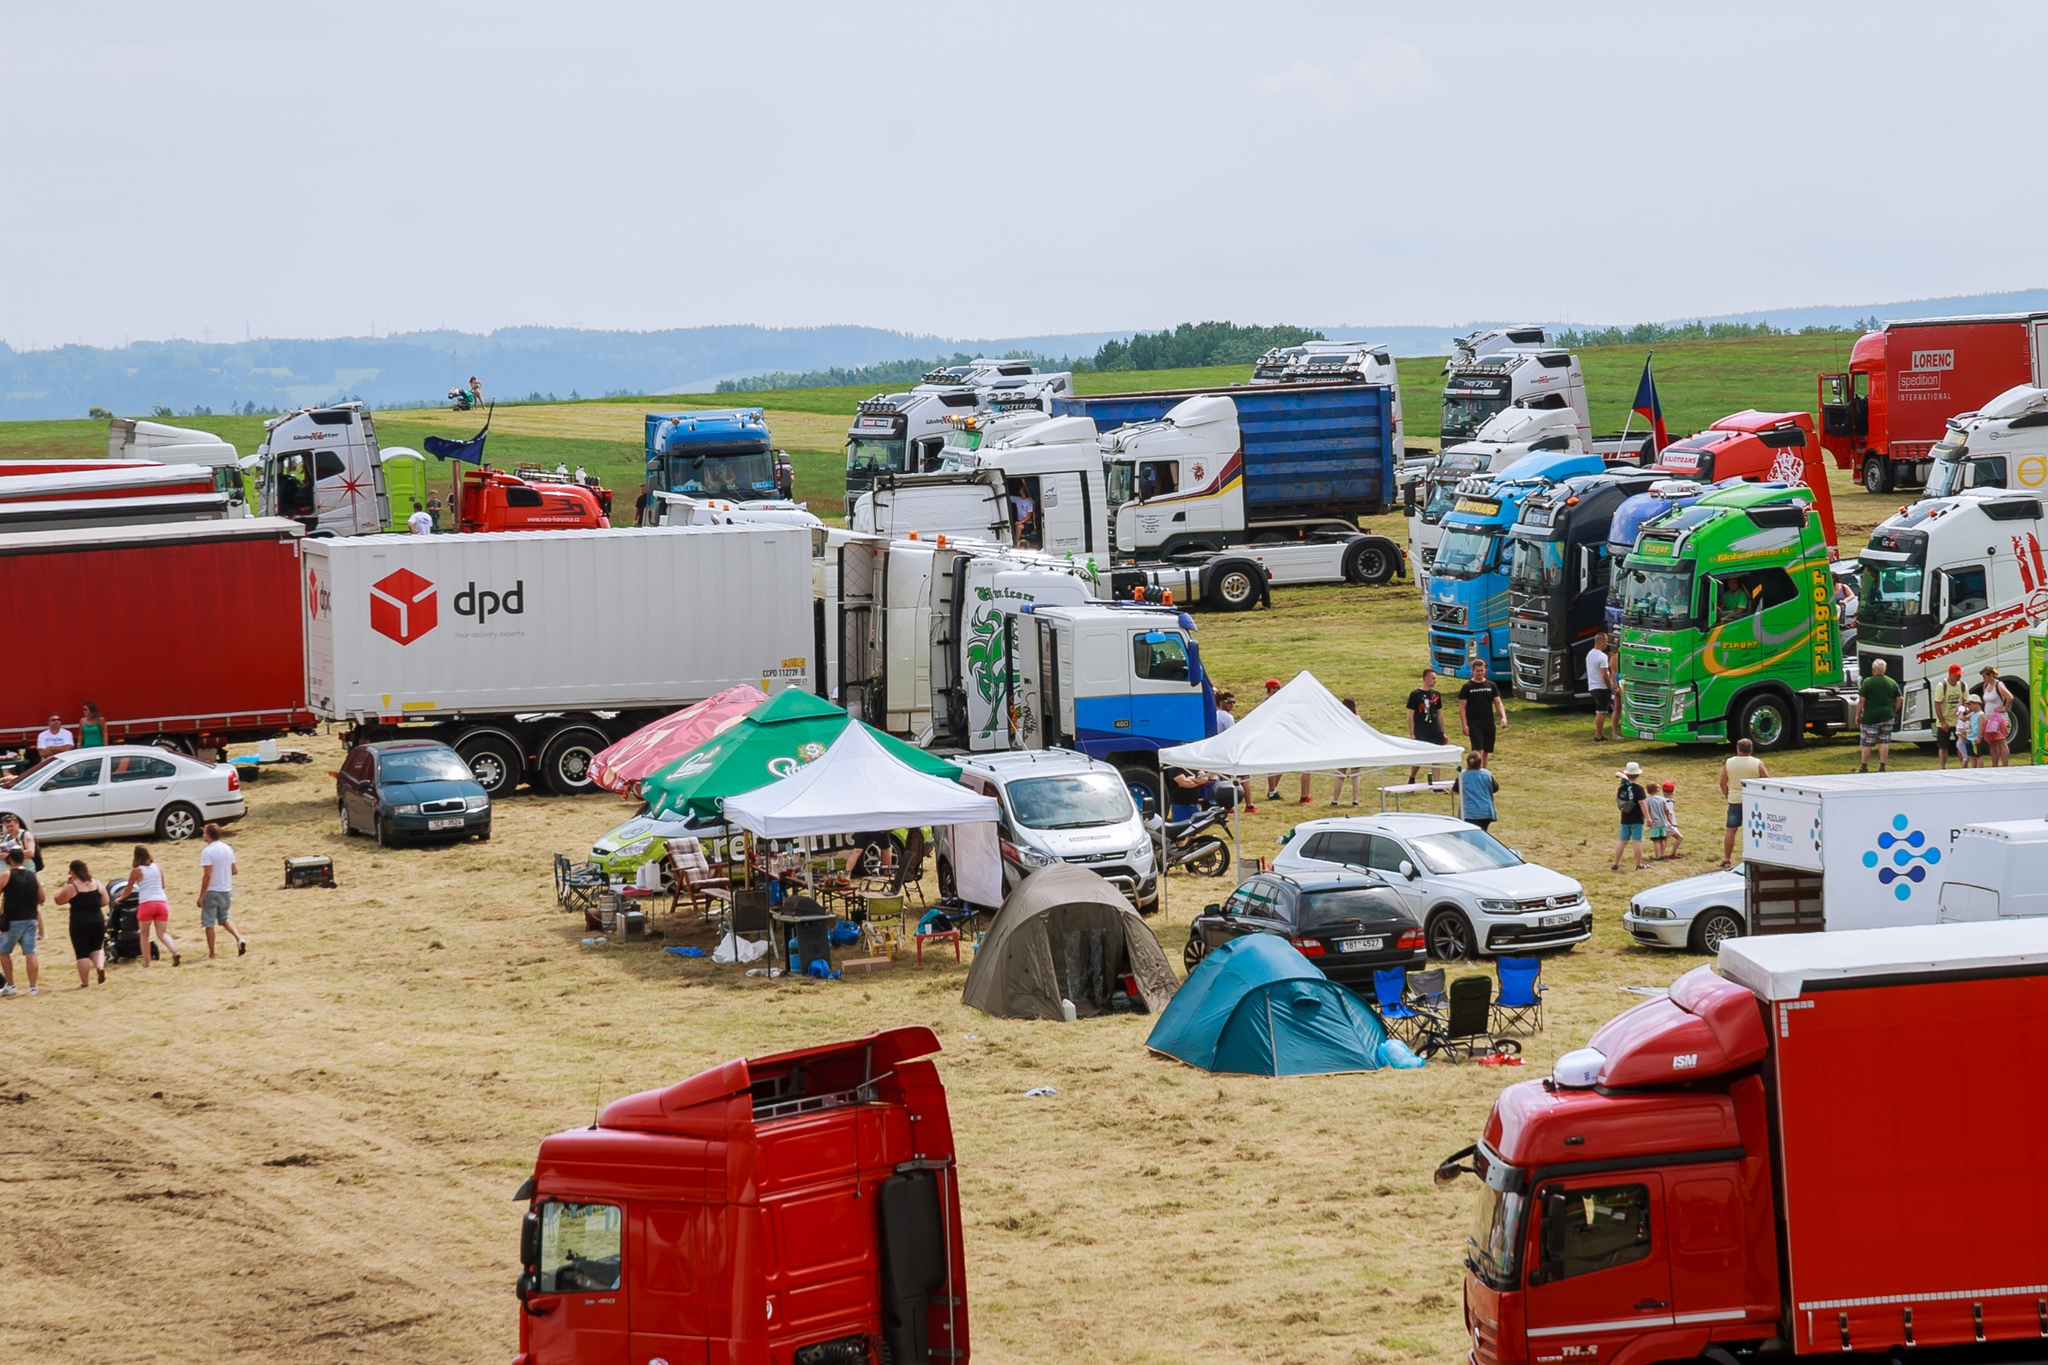Can you describe some of the activities that might be happening around these trucks? Given the setup with multiple trucks, tents, and people milling about, it’s likely that this gathering involves a variety of activities. There might be truck inspections or showcases where owners display alterations and customizations. Networking among drivers, perhaps informal discussions or planned meetings, could be another key activity. Additionally, the presence of tents and casual setups suggests food stalls, merchandise sales, or informational booths. This environment typically fosters a community atmosphere, where enthusiasts and professionals share knowledge, stories, and a passion for trucking. 